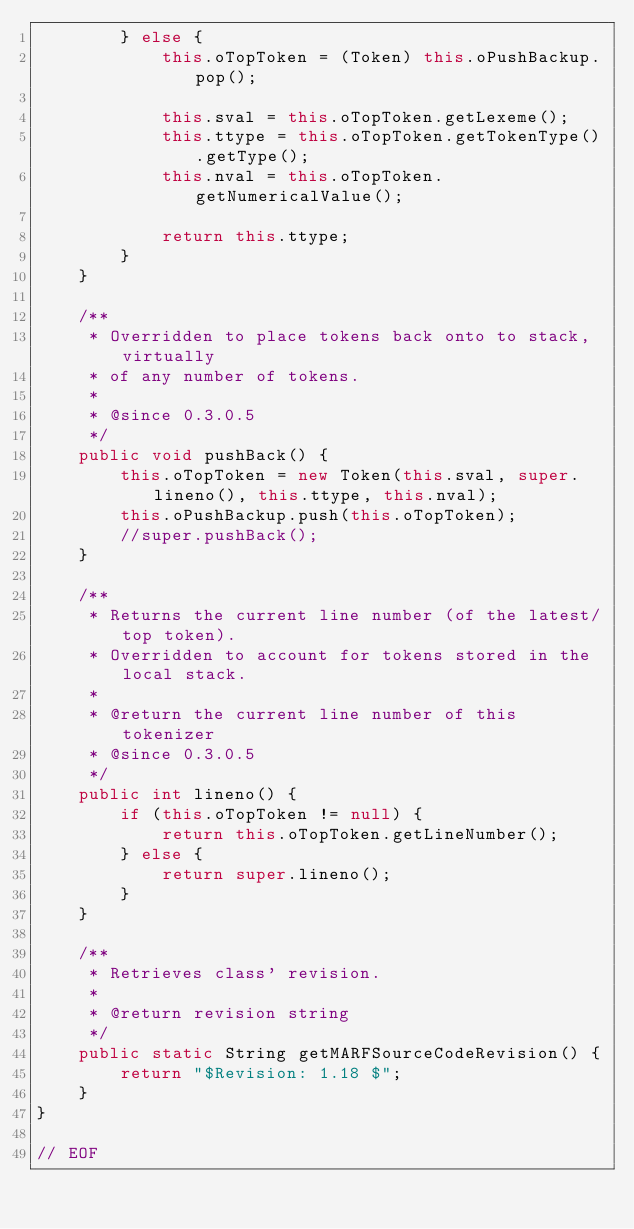<code> <loc_0><loc_0><loc_500><loc_500><_Java_>        } else {
            this.oTopToken = (Token) this.oPushBackup.pop();

            this.sval = this.oTopToken.getLexeme();
            this.ttype = this.oTopToken.getTokenType().getType();
            this.nval = this.oTopToken.getNumericalValue();

            return this.ttype;
        }
    }

    /**
     * Overridden to place tokens back onto to stack, virtually
     * of any number of tokens.
     *
     * @since 0.3.0.5
     */
    public void pushBack() {
        this.oTopToken = new Token(this.sval, super.lineno(), this.ttype, this.nval);
        this.oPushBackup.push(this.oTopToken);
        //super.pushBack();
    }

    /**
     * Returns the current line number (of the latest/top token).
     * Overridden to account for tokens stored in the local stack.
     *
     * @return the current line number of this tokenizer
     * @since 0.3.0.5
     */
    public int lineno() {
        if (this.oTopToken != null) {
            return this.oTopToken.getLineNumber();
        } else {
            return super.lineno();
        }
    }

    /**
     * Retrieves class' revision.
     *
     * @return revision string
     */
    public static String getMARFSourceCodeRevision() {
        return "$Revision: 1.18 $";
    }
}

// EOF
</code> 